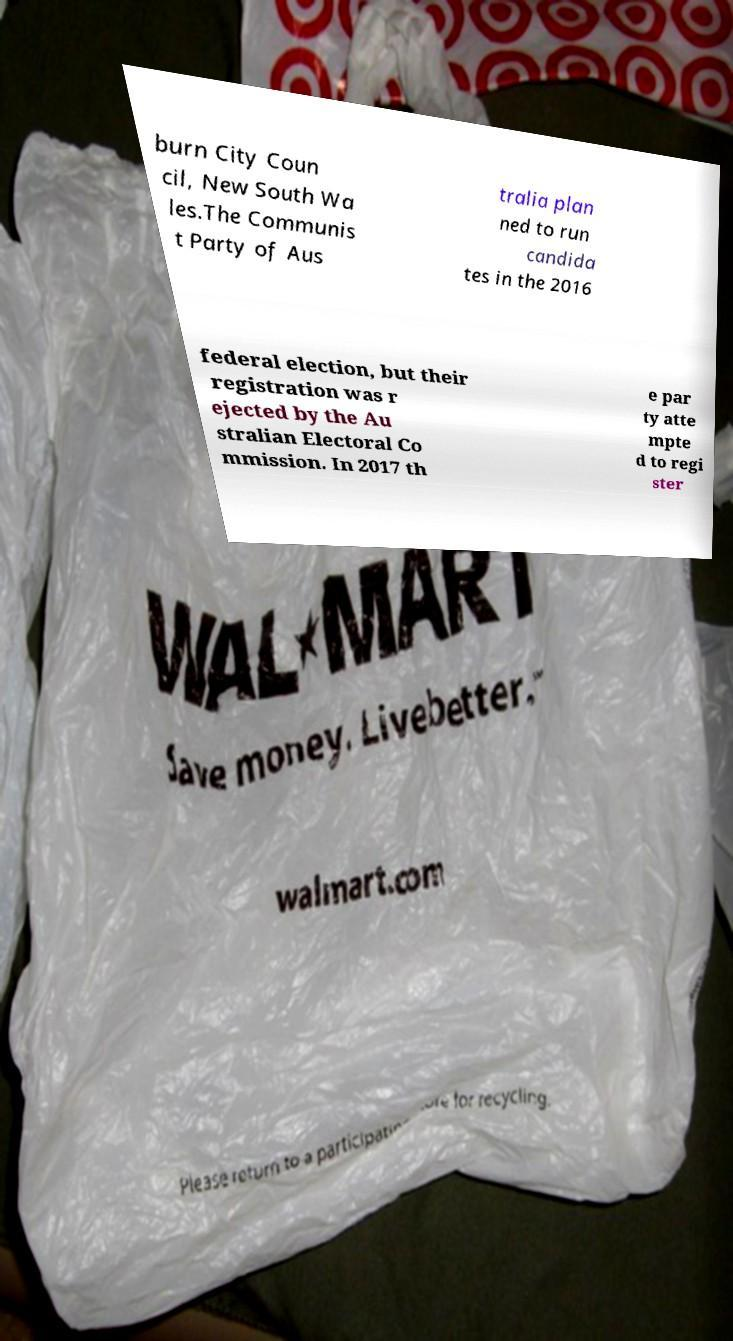For documentation purposes, I need the text within this image transcribed. Could you provide that? burn City Coun cil, New South Wa les.The Communis t Party of Aus tralia plan ned to run candida tes in the 2016 federal election, but their registration was r ejected by the Au stralian Electoral Co mmission. In 2017 th e par ty atte mpte d to regi ster 